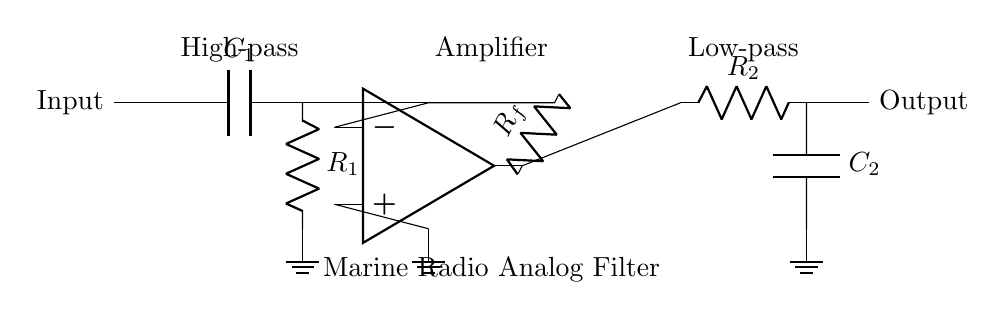What type of filter is used in the first stage? The first stage is a high-pass filter, which is indicated by the capacitor and resistor configuration at the input. A capacitor allows high-frequency signals to pass while blocking low-frequency signals.
Answer: High-pass What components are used in the feedback network? The feedback network consists of a resistor labeled R_f, which connects the output of the operational amplifier to its inverting input. This is characteristic of negative feedback which stabilizes the gain of the amplifier.
Answer: R_f How many stages are in the filter circuit? The circuit clearly demonstrates two stages: the high-pass filter stage and the low-pass filter stage, each serving a specific purpose for signal processing.
Answer: Two What does the operational amplifier do in this circuit? The operational amplifier in this circuit amplifies the signal. It takes the input from the high-pass filter and provides the necessary gain to the output, enabling better transmission in marine radio communication.
Answer: Amplifies What is the function of the capacitor C1? Capacitor C1 in the high-pass stage allows high-frequency signals to pass through while blocking low-frequency signals, contributing to the filtering effect of the circuit.
Answer: Filters high frequencies 